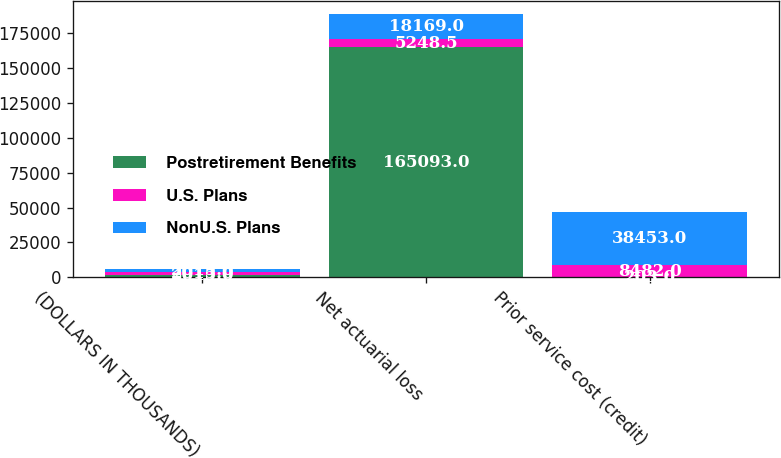Convert chart. <chart><loc_0><loc_0><loc_500><loc_500><stacked_bar_chart><ecel><fcel>(DOLLARS IN THOUSANDS)<fcel>Net actuarial loss<fcel>Prior service cost (credit)<nl><fcel>Postretirement Benefits<fcel>2015<fcel>165093<fcel>203<nl><fcel>U.S. Plans<fcel>2015<fcel>5248.5<fcel>8482<nl><fcel>NonU.S. Plans<fcel>2015<fcel>18169<fcel>38453<nl></chart> 